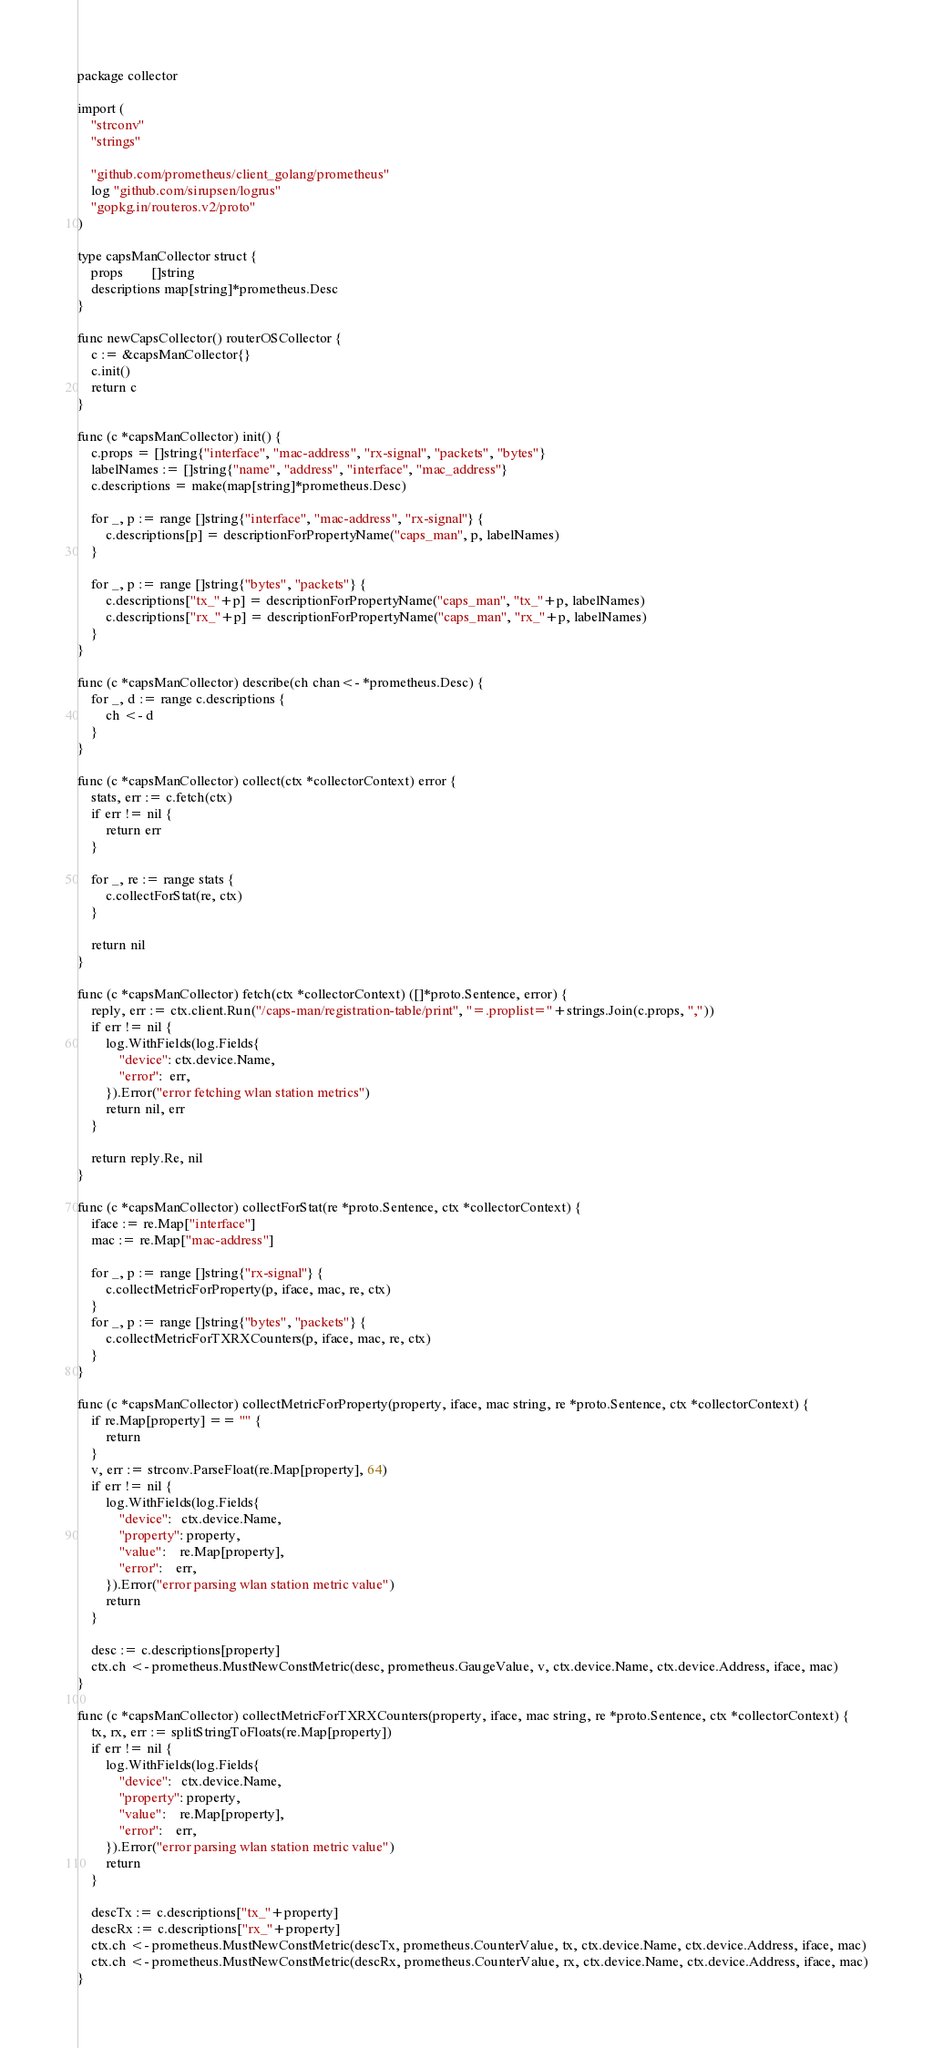<code> <loc_0><loc_0><loc_500><loc_500><_Go_>package collector

import (
	"strconv"
	"strings"

	"github.com/prometheus/client_golang/prometheus"
	log "github.com/sirupsen/logrus"
	"gopkg.in/routeros.v2/proto"
)

type capsManCollector struct {
	props        []string
	descriptions map[string]*prometheus.Desc
}

func newCapsCollector() routerOSCollector {
	c := &capsManCollector{}
	c.init()
	return c
}

func (c *capsManCollector) init() {
	c.props = []string{"interface", "mac-address", "rx-signal", "packets", "bytes"}
	labelNames := []string{"name", "address", "interface", "mac_address"}
	c.descriptions = make(map[string]*prometheus.Desc)

	for _, p := range []string{"interface", "mac-address", "rx-signal"} {
		c.descriptions[p] = descriptionForPropertyName("caps_man", p, labelNames)
	}

	for _, p := range []string{"bytes", "packets"} {
		c.descriptions["tx_"+p] = descriptionForPropertyName("caps_man", "tx_"+p, labelNames)
		c.descriptions["rx_"+p] = descriptionForPropertyName("caps_man", "rx_"+p, labelNames)
	}
}

func (c *capsManCollector) describe(ch chan<- *prometheus.Desc) {
	for _, d := range c.descriptions {
		ch <- d
	}
}

func (c *capsManCollector) collect(ctx *collectorContext) error {
	stats, err := c.fetch(ctx)
	if err != nil {
		return err
	}

	for _, re := range stats {
		c.collectForStat(re, ctx)
	}

	return nil
}

func (c *capsManCollector) fetch(ctx *collectorContext) ([]*proto.Sentence, error) {
	reply, err := ctx.client.Run("/caps-man/registration-table/print", "=.proplist="+strings.Join(c.props, ","))
	if err != nil {
		log.WithFields(log.Fields{
			"device": ctx.device.Name,
			"error":  err,
		}).Error("error fetching wlan station metrics")
		return nil, err
	}

	return reply.Re, nil
}

func (c *capsManCollector) collectForStat(re *proto.Sentence, ctx *collectorContext) {
	iface := re.Map["interface"]
	mac := re.Map["mac-address"]

	for _, p := range []string{"rx-signal"} {
		c.collectMetricForProperty(p, iface, mac, re, ctx)
	}
	for _, p := range []string{"bytes", "packets"} {
		c.collectMetricForTXRXCounters(p, iface, mac, re, ctx)
	}
}

func (c *capsManCollector) collectMetricForProperty(property, iface, mac string, re *proto.Sentence, ctx *collectorContext) {
	if re.Map[property] == "" {
		return
	}
	v, err := strconv.ParseFloat(re.Map[property], 64)
	if err != nil {
		log.WithFields(log.Fields{
			"device":   ctx.device.Name,
			"property": property,
			"value":    re.Map[property],
			"error":    err,
		}).Error("error parsing wlan station metric value")
		return
	}

	desc := c.descriptions[property]
	ctx.ch <- prometheus.MustNewConstMetric(desc, prometheus.GaugeValue, v, ctx.device.Name, ctx.device.Address, iface, mac)
}

func (c *capsManCollector) collectMetricForTXRXCounters(property, iface, mac string, re *proto.Sentence, ctx *collectorContext) {
	tx, rx, err := splitStringToFloats(re.Map[property])
	if err != nil {
		log.WithFields(log.Fields{
			"device":   ctx.device.Name,
			"property": property,
			"value":    re.Map[property],
			"error":    err,
		}).Error("error parsing wlan station metric value")
		return
	}

	descTx := c.descriptions["tx_"+property]
	descRx := c.descriptions["rx_"+property]
	ctx.ch <- prometheus.MustNewConstMetric(descTx, prometheus.CounterValue, tx, ctx.device.Name, ctx.device.Address, iface, mac)
	ctx.ch <- prometheus.MustNewConstMetric(descRx, prometheus.CounterValue, rx, ctx.device.Name, ctx.device.Address, iface, mac)
}
</code> 